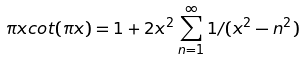Convert formula to latex. <formula><loc_0><loc_0><loc_500><loc_500>\pi x c o t ( \pi x ) = 1 + 2 x ^ { 2 } \sum _ { n = 1 } ^ { \infty } 1 / ( x ^ { 2 } - n ^ { 2 } )</formula> 